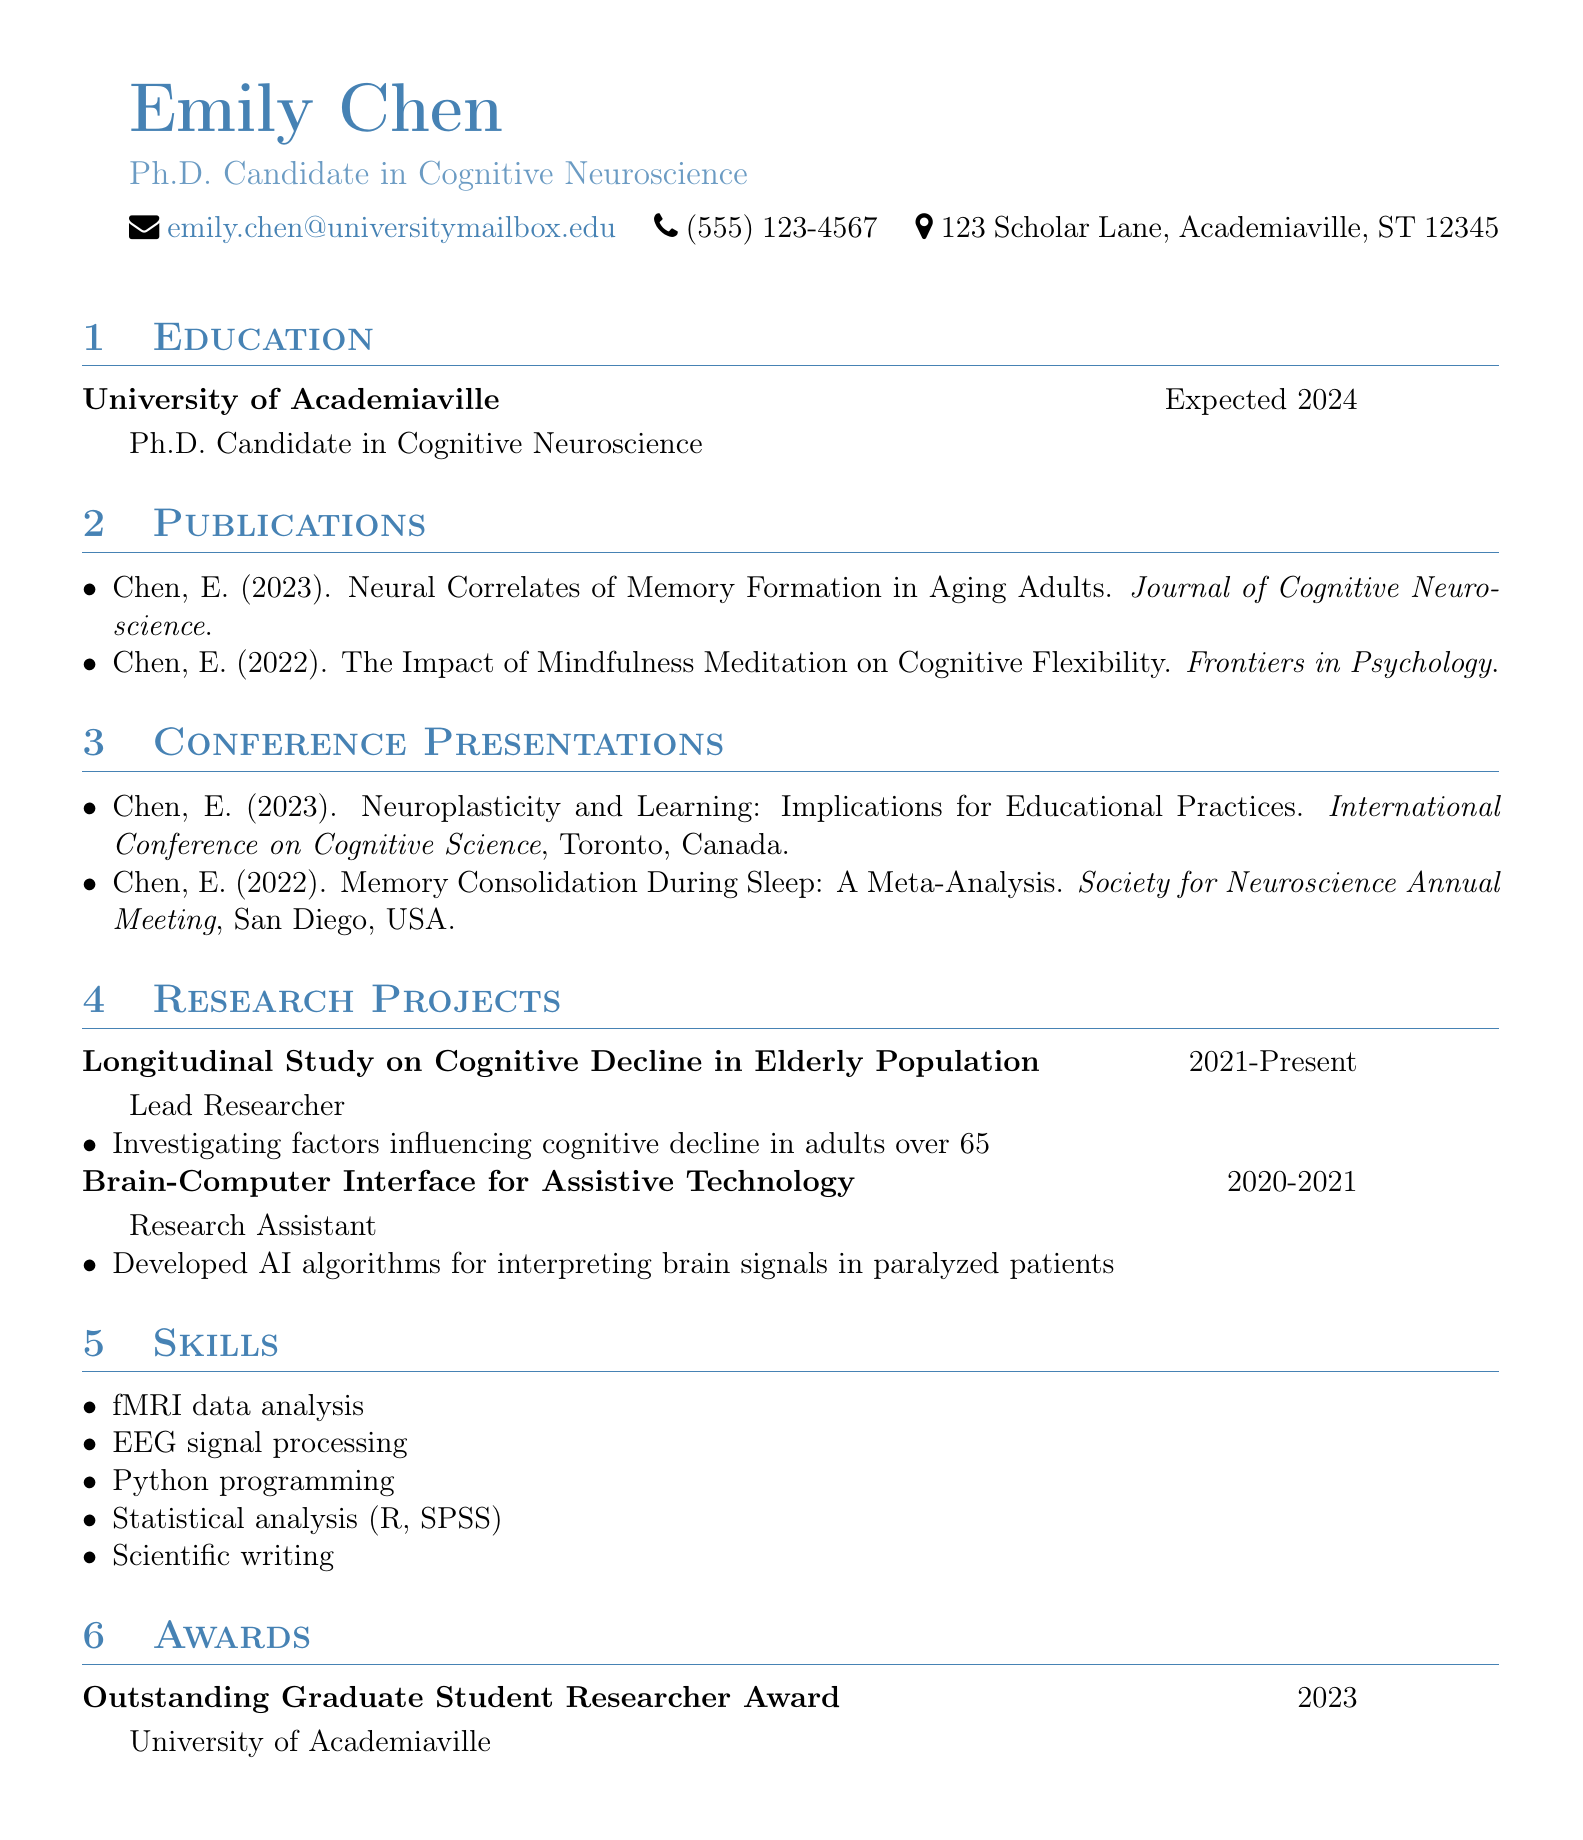What is Emily Chen's expected graduation year? The expected graduation year is mentioned under the education section for Emily Chen, which is 2024.
Answer: 2024 How many publications does Emily Chen have listed? The publications section lists two titles authored by Emily Chen.
Answer: 2 What role did Emily Chen have in her longitudinal study project? The role for the longitudinal study project is specified in the research projects section, which lists her as the Lead Researcher.
Answer: Lead Researcher Which journal published Emily Chen's 2023 paper? The journal where the paper titled "Neural Correlates of Memory Formation in Aging Adults" was published is mentioned in the publications section.
Answer: Journal of Cognitive Neuroscience In what year was the Outstanding Graduate Student Researcher Award received? The year for the award is provided in the awards section, specifically stating it was awarded in 2023.
Answer: 2023 Where was the International Conference on Cognitive Science held? The location for the conference presentation is noted in the conference presentations section, specifying Toronto, Canada.
Answer: Toronto, Canada What is the focus of Emily Chen's research project on cognitive decline? The description of the research project mentions the focus is on factors influencing cognitive decline in adults over 65.
Answer: Cognitive decline in adults over 65 What programming language is mentioned as one of Emily Chen's skills? The skills section includes Python programming, highlighting one of her technical competencies.
Answer: Python What is the title of Emily Chen's conference presentation in 2022? The title is listed in the conference presentations section, specifically stating "Memory Consolidation During Sleep: A Meta-Analysis."
Answer: Memory Consolidation During Sleep: A Meta-Analysis 